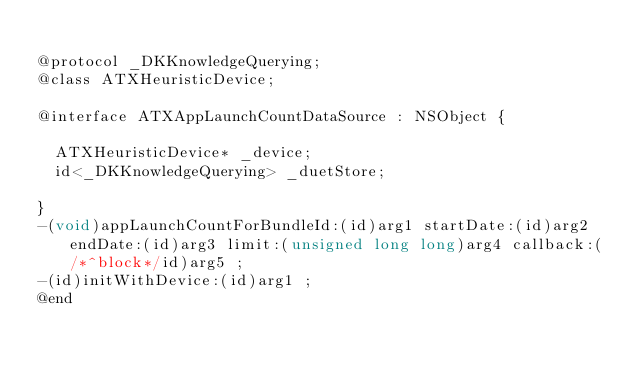Convert code to text. <code><loc_0><loc_0><loc_500><loc_500><_C_>
@protocol _DKKnowledgeQuerying;
@class ATXHeuristicDevice;

@interface ATXAppLaunchCountDataSource : NSObject {

	ATXHeuristicDevice* _device;
	id<_DKKnowledgeQuerying> _duetStore;

}
-(void)appLaunchCountForBundleId:(id)arg1 startDate:(id)arg2 endDate:(id)arg3 limit:(unsigned long long)arg4 callback:(/*^block*/id)arg5 ;
-(id)initWithDevice:(id)arg1 ;
@end

</code> 